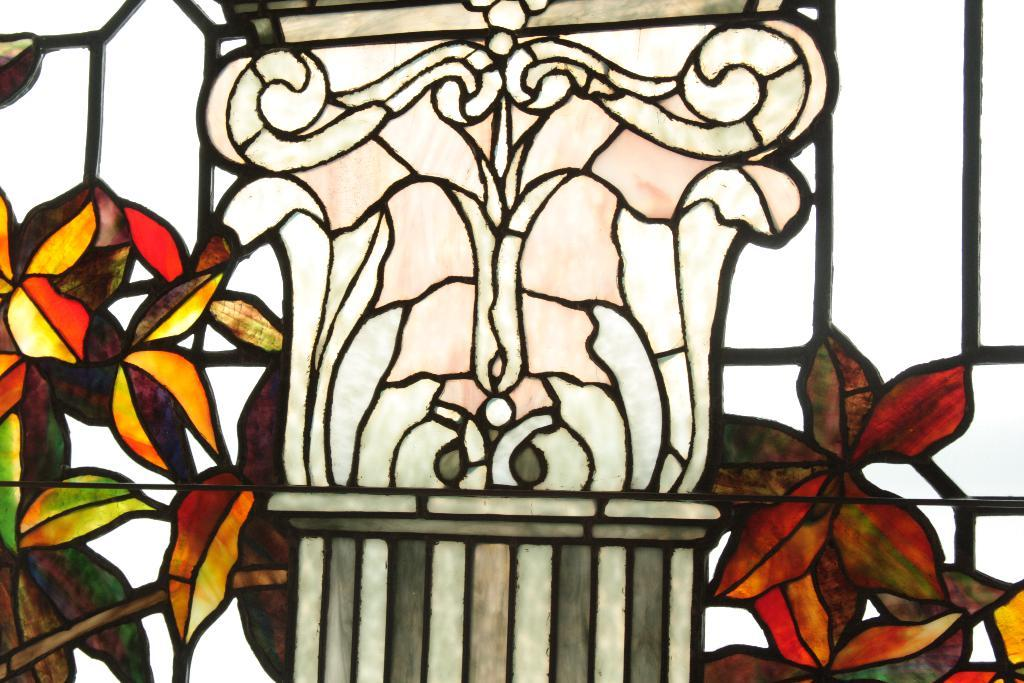What object in the image reflects an image? There is a mirror in the image that reflects an image. What is depicted on the mirror? There is a painting of a plant on the mirror. What can be seen within the painting on the mirror? There is a pillar in the painting on the mirror. What grade does the boat receive in the image? There is no boat present in the image, so it is not possible to determine a grade for it. 